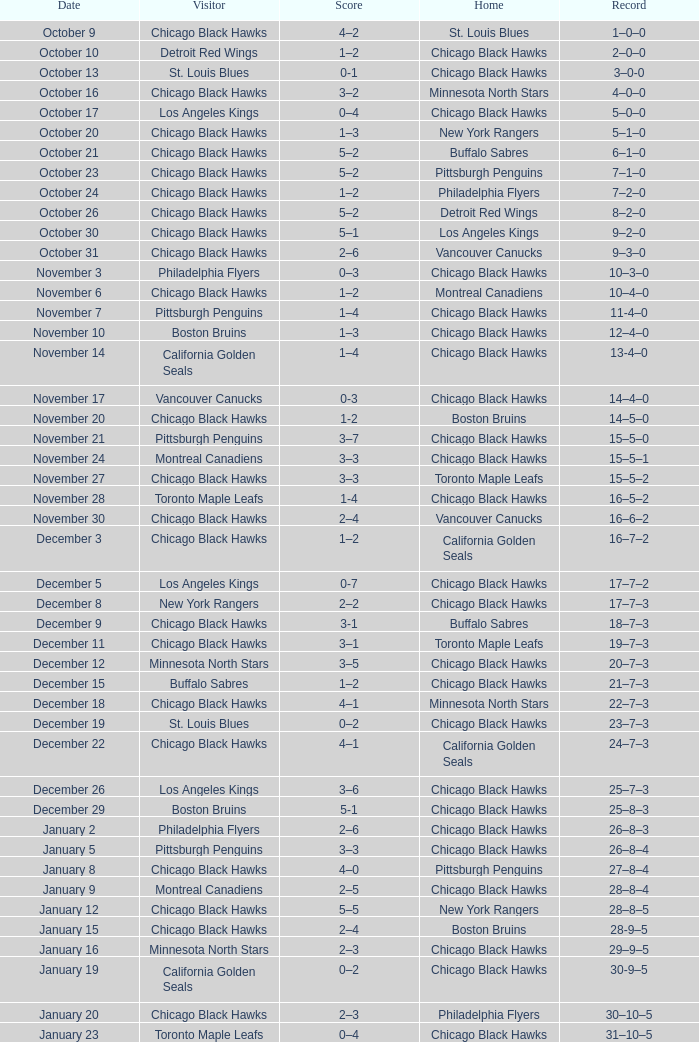What is the Score of the Chicago Black Hawks Home game with the Visiting Vancouver Canucks on November 17? 0-3. 